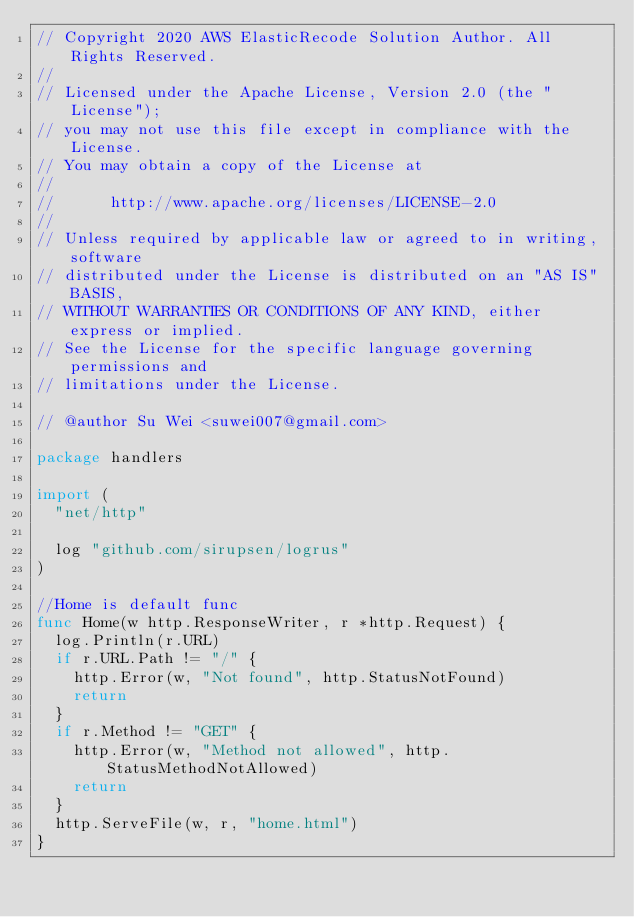Convert code to text. <code><loc_0><loc_0><loc_500><loc_500><_Go_>// Copyright 2020 AWS ElasticRecode Solution Author. All Rights Reserved.
//
// Licensed under the Apache License, Version 2.0 (the "License");
// you may not use this file except in compliance with the License.
// You may obtain a copy of the License at
//
//      http://www.apache.org/licenses/LICENSE-2.0
//
// Unless required by applicable law or agreed to in writing, software
// distributed under the License is distributed on an "AS IS" BASIS,
// WITHOUT WARRANTIES OR CONDITIONS OF ANY KIND, either express or implied.
// See the License for the specific language governing permissions and
// limitations under the License.

// @author Su Wei <suwei007@gmail.com>

package handlers

import (
	"net/http"

	log "github.com/sirupsen/logrus"
)

//Home is default func
func Home(w http.ResponseWriter, r *http.Request) {
	log.Println(r.URL)
	if r.URL.Path != "/" {
		http.Error(w, "Not found", http.StatusNotFound)
		return
	}
	if r.Method != "GET" {
		http.Error(w, "Method not allowed", http.StatusMethodNotAllowed)
		return
	}
	http.ServeFile(w, r, "home.html")
}
</code> 